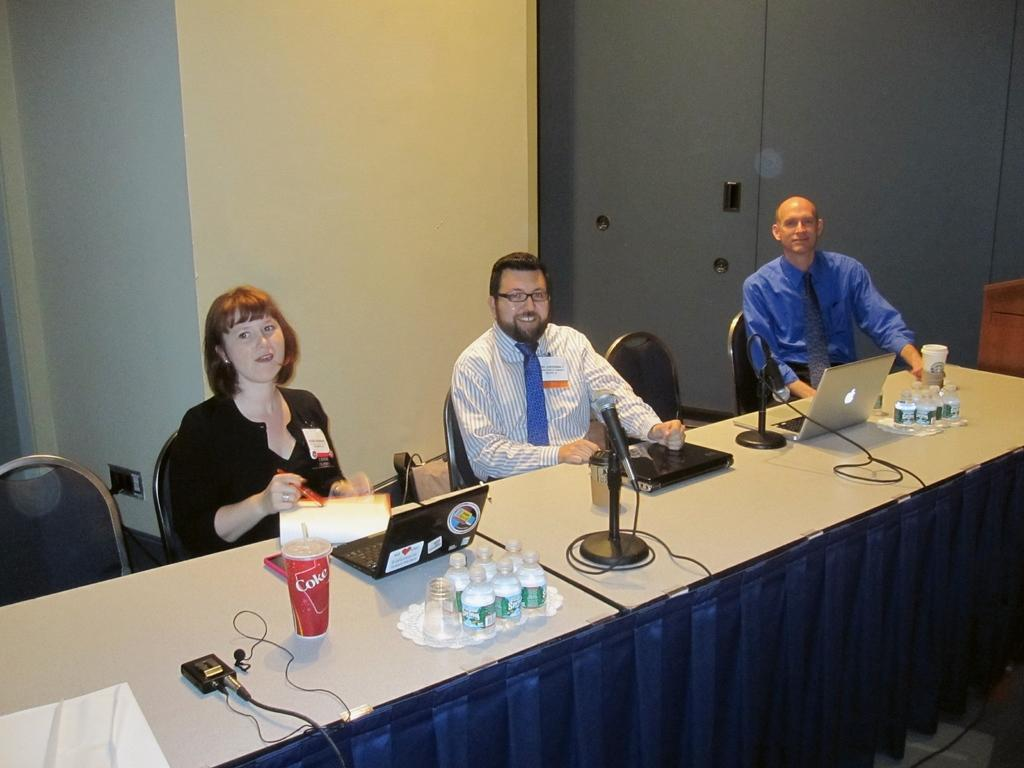What are the people in the image doing? The persons sitting in the room are likely engaged in some activity or conversation. What furniture is present in the room? There is a table in the room. What items can be seen on the table? There is a Coke, a laptop, a bottle, and a microphone on the table. What can be seen in the background of the image? There is a cupboard visible in the background. What type of boats can be seen sailing in the background of the image? There are no boats visible in the background of the image; it features a room with a table and various objects on it. Is there a band playing in the room in the image? There is no indication of a band or any musical instruments in the image. 